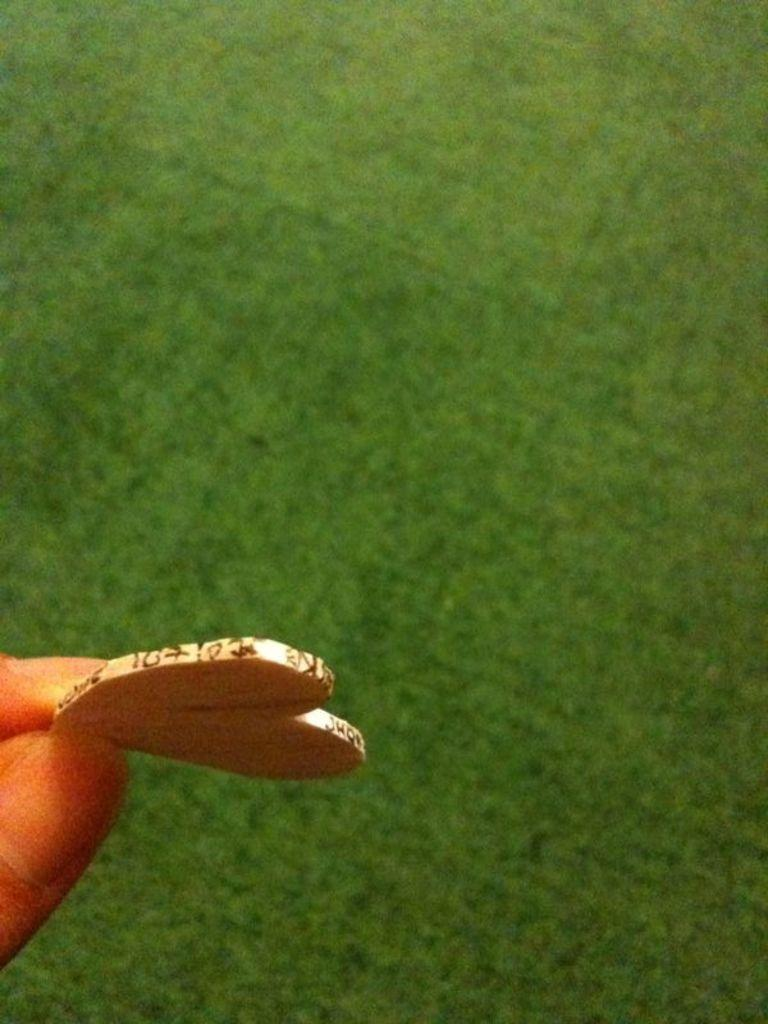What is being held by the person's hand on the left side of the image? There is an object being held by a person's hand on the left side of the image. What type of surface can be seen in the center of the image? There is grass on the ground in the center of the image. What type of rake is being used by the fireman in the image? There is no rake or fireman present in the image. What kind of offer is being made by the person in the image? There is no offer being made in the image; it only shows a person's hand holding an object and grass on the ground. 